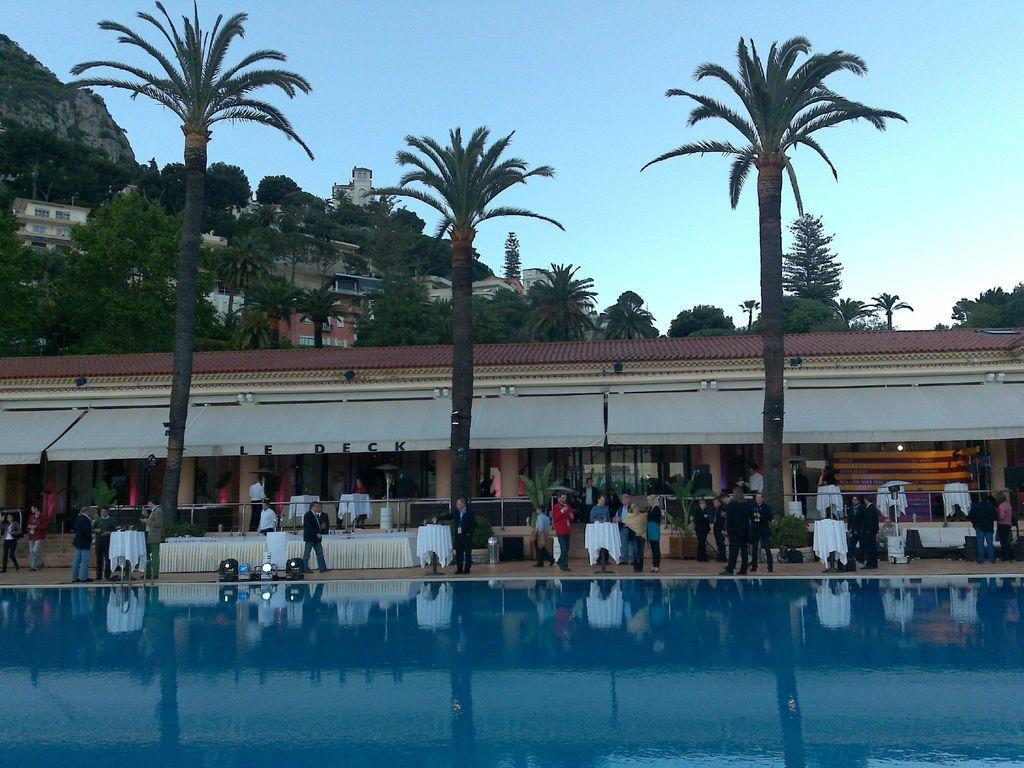In one or two sentences, can you explain what this image depicts? In this image we can see the buildings, hill, trees, tables, lights and also the pool at the bottom. We can also see the people. Sky is also visible in this image. 